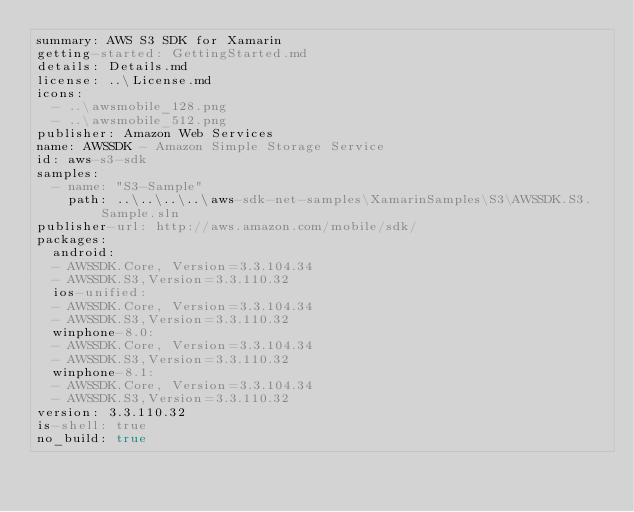<code> <loc_0><loc_0><loc_500><loc_500><_YAML_>summary: AWS S3 SDK for Xamarin
getting-started: GettingStarted.md
details: Details.md
license: ..\License.md
icons: 
  - ..\awsmobile_128.png
  - ..\awsmobile_512.png
publisher: Amazon Web Services
name: AWSSDK - Amazon Simple Storage Service
id: aws-s3-sdk
samples: 
  - name: "S3-Sample"
    path: ..\..\..\..\aws-sdk-net-samples\XamarinSamples\S3\AWSSDK.S3.Sample.sln
publisher-url: http://aws.amazon.com/mobile/sdk/
packages:
  android:
  - AWSSDK.Core, Version=3.3.104.34
  - AWSSDK.S3,Version=3.3.110.32
  ios-unified:
  - AWSSDK.Core, Version=3.3.104.34
  - AWSSDK.S3,Version=3.3.110.32
  winphone-8.0:
  - AWSSDK.Core, Version=3.3.104.34
  - AWSSDK.S3,Version=3.3.110.32
  winphone-8.1:
  - AWSSDK.Core, Version=3.3.104.34
  - AWSSDK.S3,Version=3.3.110.32
version: 3.3.110.32
is-shell: true
no_build: true</code> 